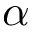Convert formula to latex. <formula><loc_0><loc_0><loc_500><loc_500>\alpha</formula> 